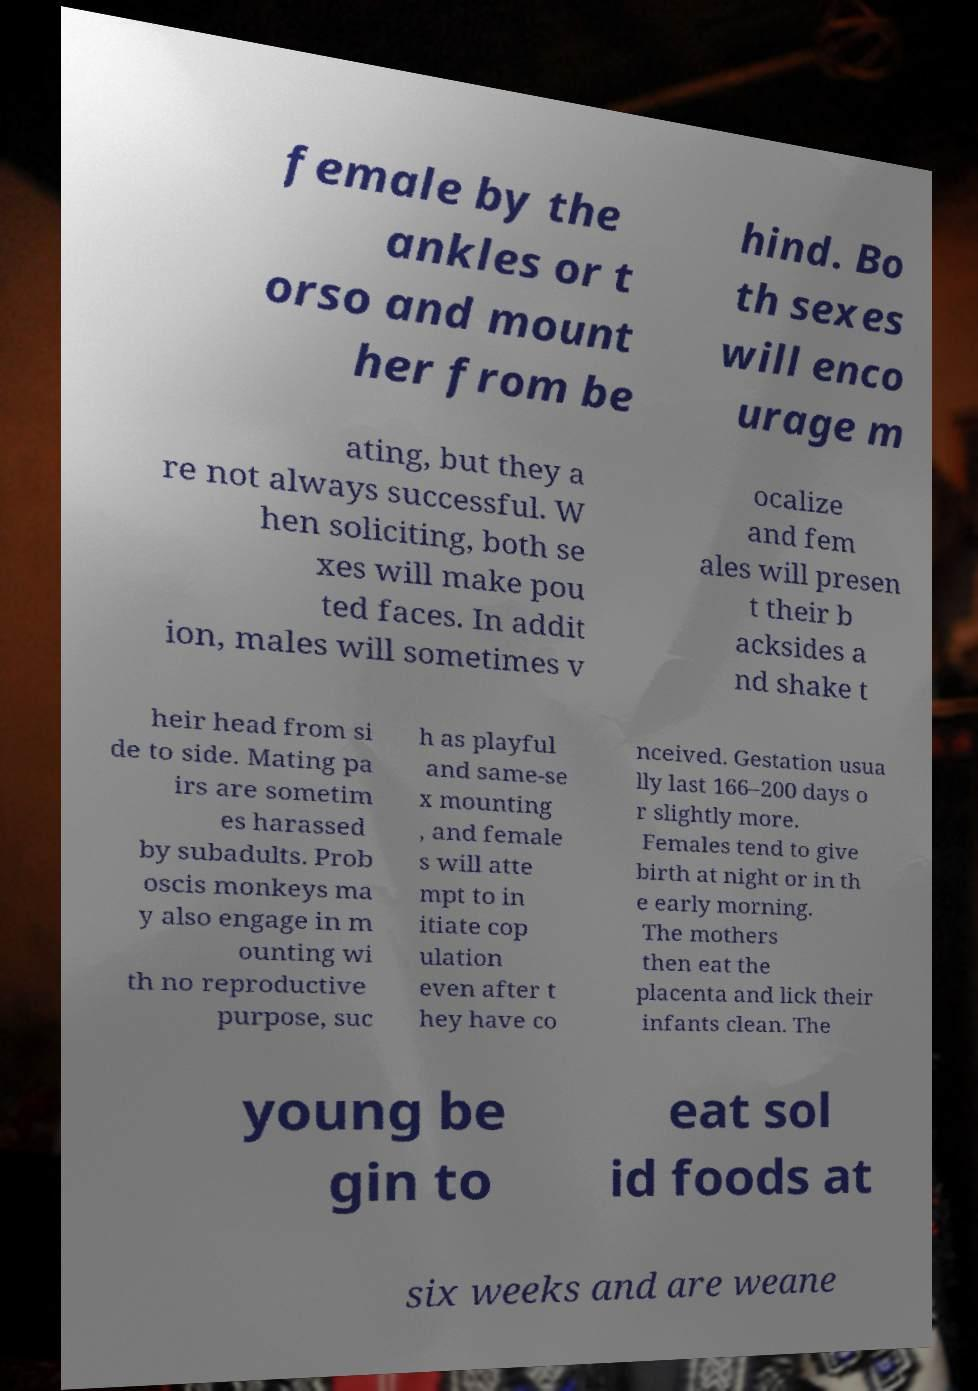What messages or text are displayed in this image? I need them in a readable, typed format. female by the ankles or t orso and mount her from be hind. Bo th sexes will enco urage m ating, but they a re not always successful. W hen soliciting, both se xes will make pou ted faces. In addit ion, males will sometimes v ocalize and fem ales will presen t their b acksides a nd shake t heir head from si de to side. Mating pa irs are sometim es harassed by subadults. Prob oscis monkeys ma y also engage in m ounting wi th no reproductive purpose, suc h as playful and same-se x mounting , and female s will atte mpt to in itiate cop ulation even after t hey have co nceived. Gestation usua lly last 166–200 days o r slightly more. Females tend to give birth at night or in th e early morning. The mothers then eat the placenta and lick their infants clean. The young be gin to eat sol id foods at six weeks and are weane 